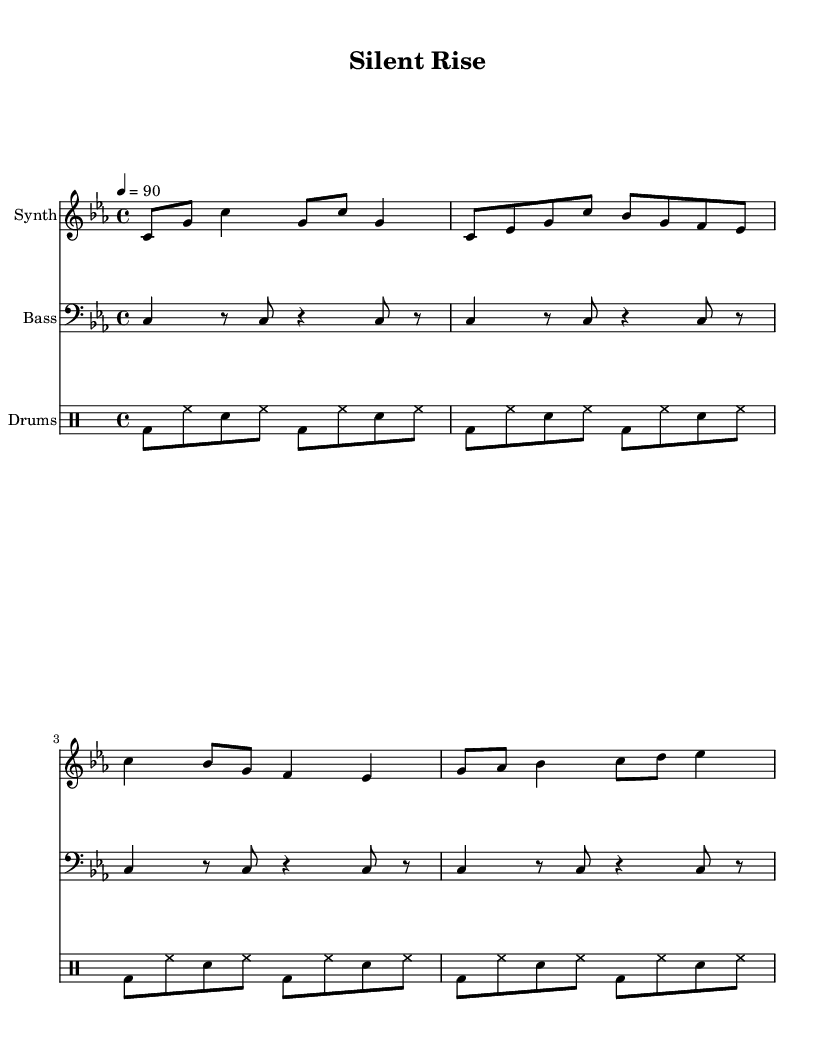what is the key signature of this music? The key signature is C minor, which is indicated by three flats (B, E, and A). In the music sheet, the key signature appears at the beginning, setting the tonality of the piece.
Answer: C minor what is the time signature of this music? The time signature is 4/4, which indicates that there are four beats in each measure and that the quarter note gets one beat. This can be observed at the beginning of the sheet music where the time signature is displayed.
Answer: 4/4 what is the tempo marking of the music? The tempo marking is quarter note equals 90, which means that each quarter note should be played at a speed of 90 beats per minute. This is indicated at the beginning of the score alongside the time signature.
Answer: 90 BPM how many measures are in the synth music section? The synth music section consists of four measures, as seen by counting the number of groupings of vertical lines (bar lines) in the staff for synth music. Each grouping represents the end of a measure.
Answer: 4 which instrument plays the bass part? The instrument that plays the bass part is designated as "Bass" in the score header for that staff, which specifies the sound associated with that particular music line.
Answer: Bass how does the drum pattern contribute to the overall style of the music? The drum pattern, characterized by a repetitive beat with bass and snare interplay, reinforces the rhythmic structure typical of rap music, providing a driving force for the lyrics and enhancing the overall groove. The consistent backbeat is vital for rap, promoting a danceable quality while allowing the verses to flow over it.
Answer: Reinforces rhythm what is the primary mood the music aims to convey? The primary mood of the music is motivational and empowering, as indicated by the upbeat tempo and rhythmic drive commonly used in motivational rap songs, which aim to inspire listeners to pursue their dreams and ambitions.
Answer: Motivational 